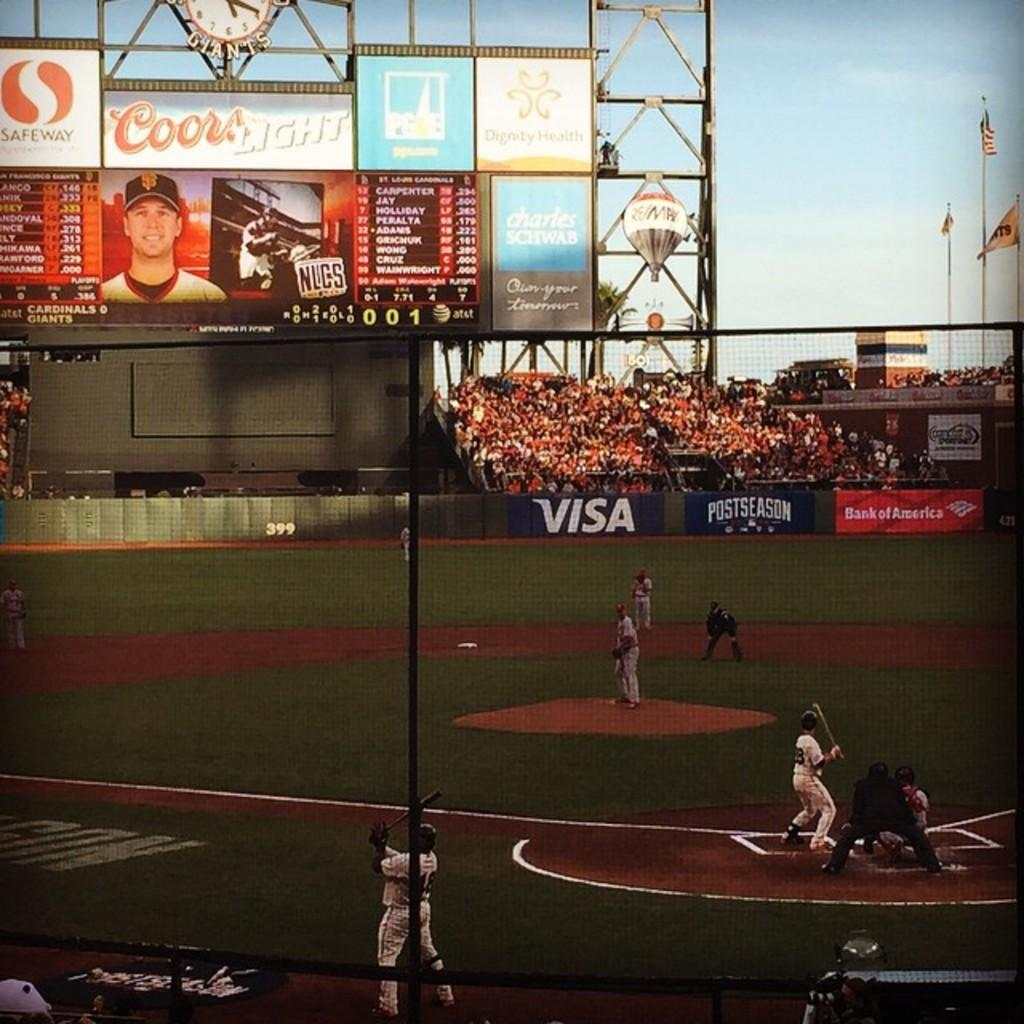<image>
Relay a brief, clear account of the picture shown. a baseball stadium with visa and bank of america sponsors 